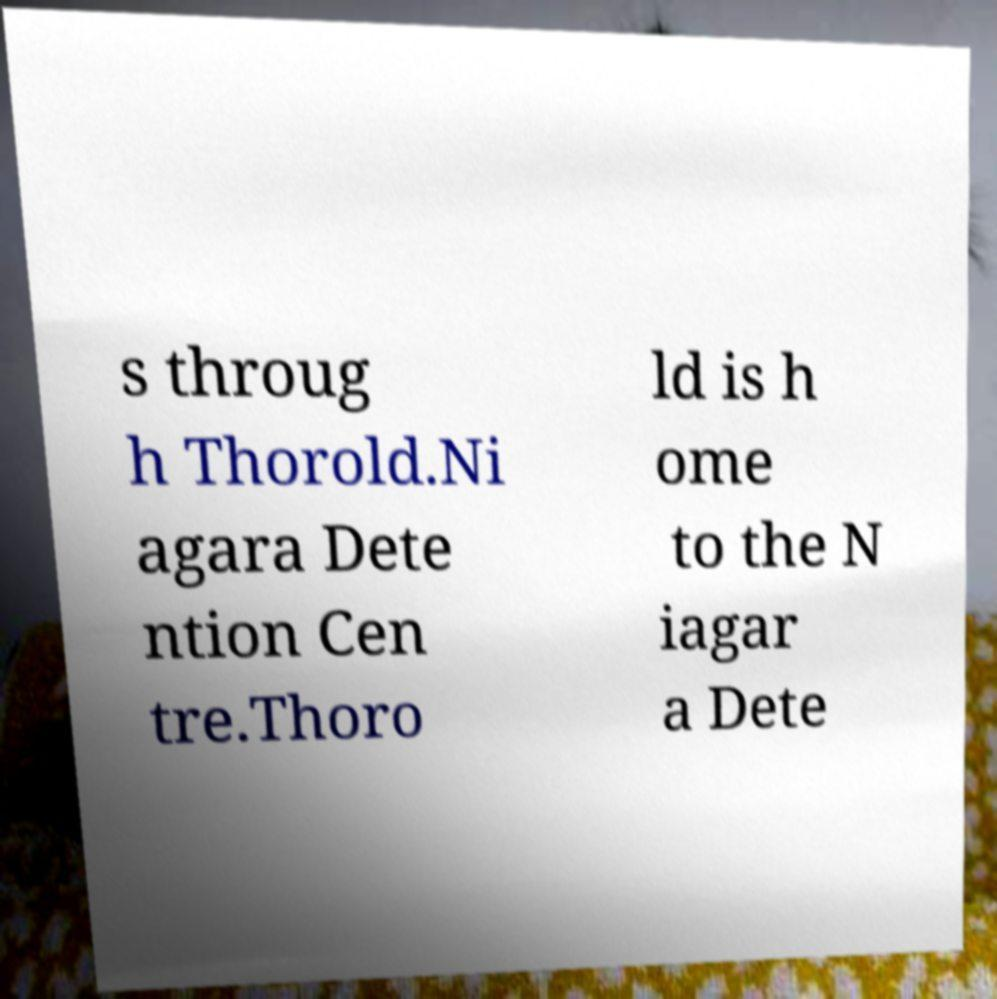I need the written content from this picture converted into text. Can you do that? s throug h Thorold.Ni agara Dete ntion Cen tre.Thoro ld is h ome to the N iagar a Dete 